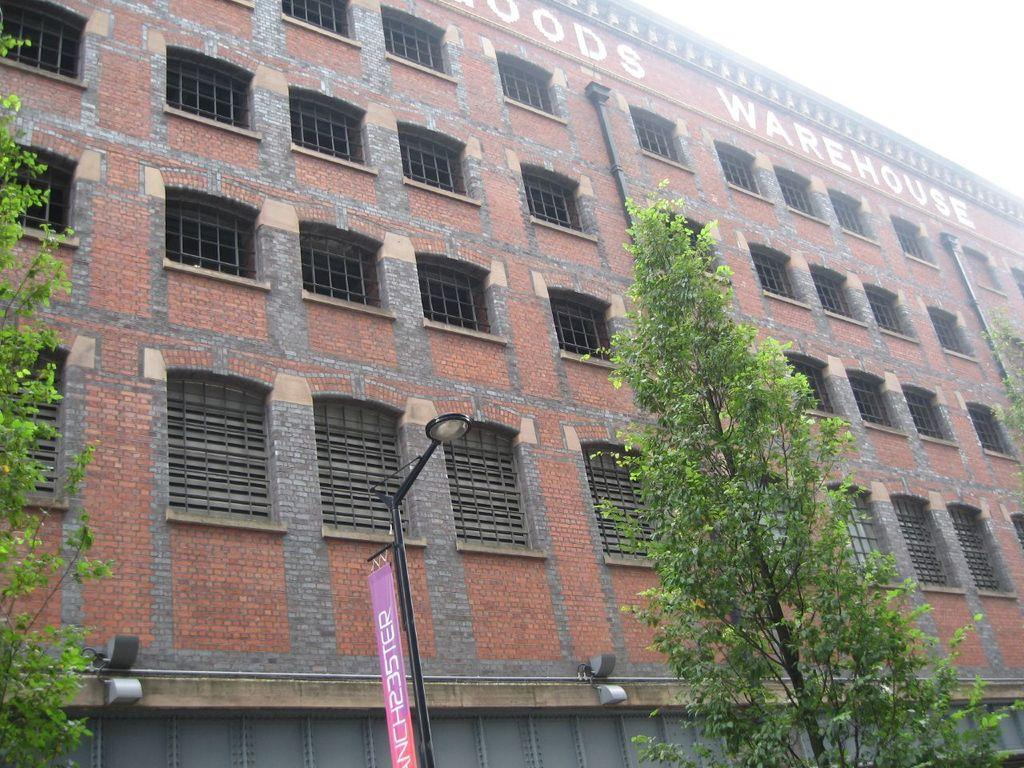What type of structure is present in the image? There is a building in the image. What feature can be seen on the building? The building has windows. What other objects are visible in the image? There is a wall, trees, a light pole, a banner, and pipes in the image. Is there any text visible in the image? Yes, there is text visible on the building. What part of the natural environment can be seen in the image? The sky is visible in the top right corner of the image. Reasoning: Let' Let's think step by step in order to produce the conversation. We start by identifying the main subject in the image, which is the building. Then, we expand the conversation to include other objects and features that are also visible, such as per the provided facts. Each question is designed to elicit a specific detail about the image that is known from the given information. Absurd Question/Answer: What type of nerve can be seen in the image? There is no nerve present in the image; it contains a building, a wall, trees, a light pole, a banner, pipes, and text on the building. Is there a box visible in the image? There is no box present in the image. 